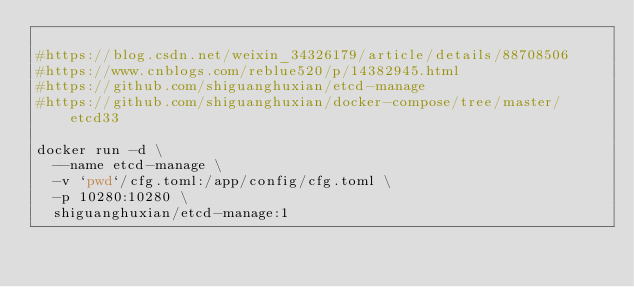Convert code to text. <code><loc_0><loc_0><loc_500><loc_500><_Bash_>
#https://blog.csdn.net/weixin_34326179/article/details/88708506
#https://www.cnblogs.com/reblue520/p/14382945.html
#https://github.com/shiguanghuxian/etcd-manage
#https://github.com/shiguanghuxian/docker-compose/tree/master/etcd33

docker run -d \
	--name etcd-manage \
	-v `pwd`/cfg.toml:/app/config/cfg.toml \
	-p 10280:10280 \
	shiguanghuxian/etcd-manage:1

</code> 